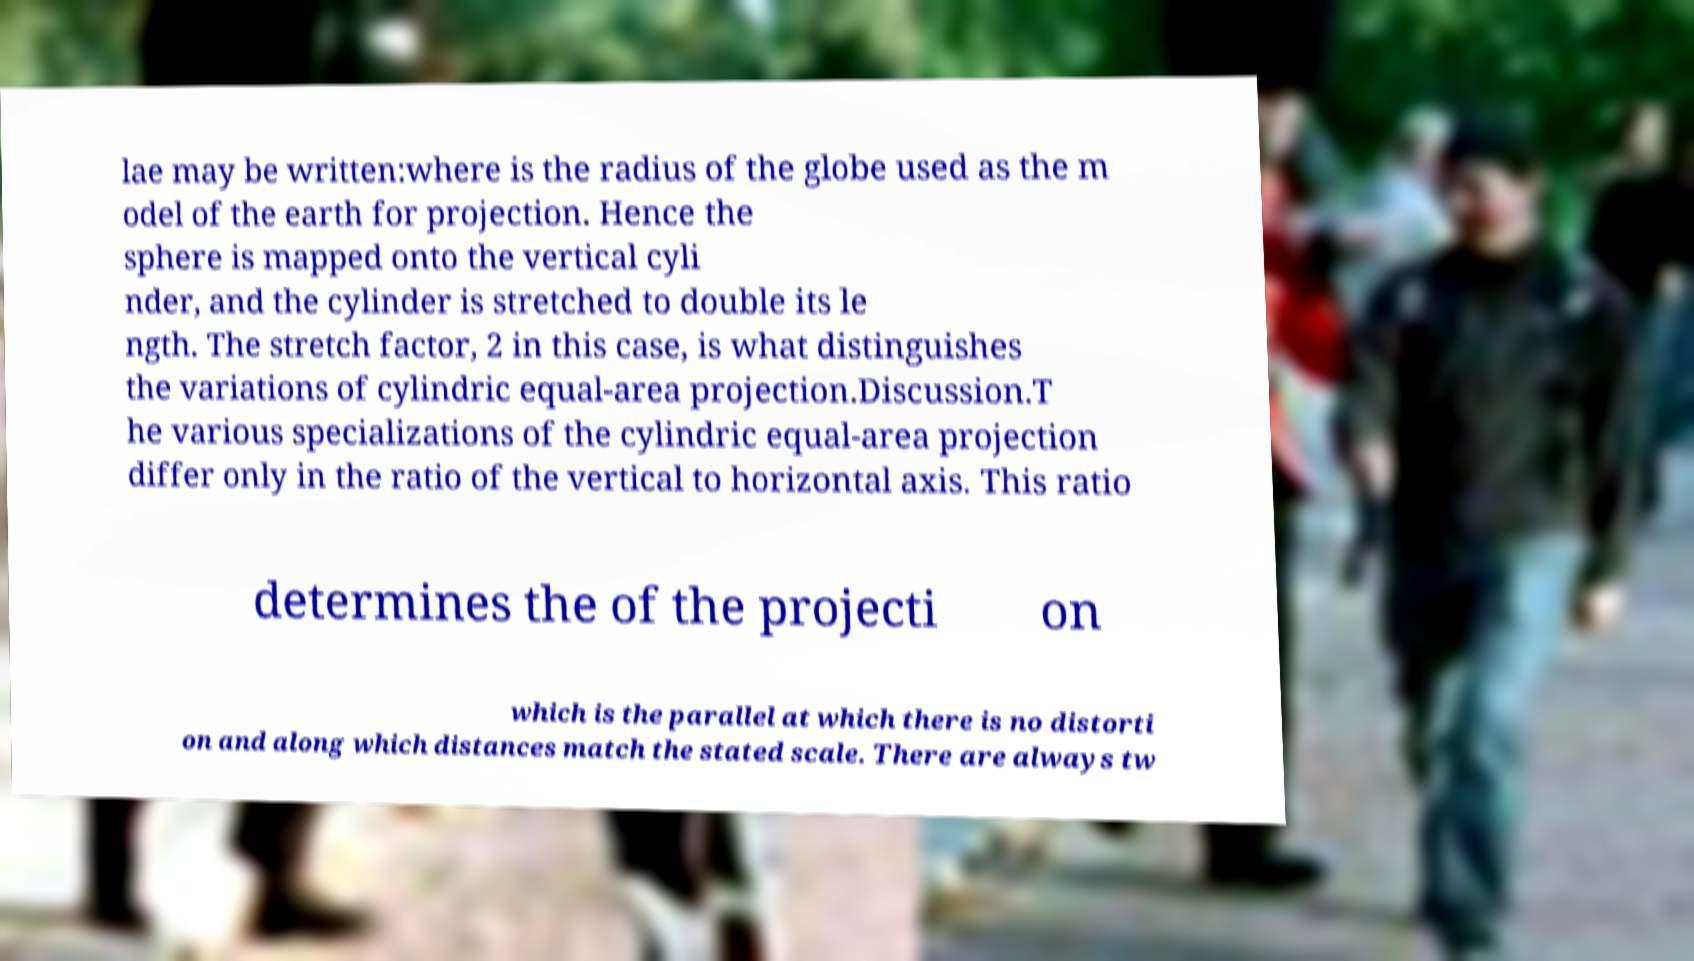For documentation purposes, I need the text within this image transcribed. Could you provide that? lae may be written:where is the radius of the globe used as the m odel of the earth for projection. Hence the sphere is mapped onto the vertical cyli nder, and the cylinder is stretched to double its le ngth. The stretch factor, 2 in this case, is what distinguishes the variations of cylindric equal-area projection.Discussion.T he various specializations of the cylindric equal-area projection differ only in the ratio of the vertical to horizontal axis. This ratio determines the of the projecti on which is the parallel at which there is no distorti on and along which distances match the stated scale. There are always tw 